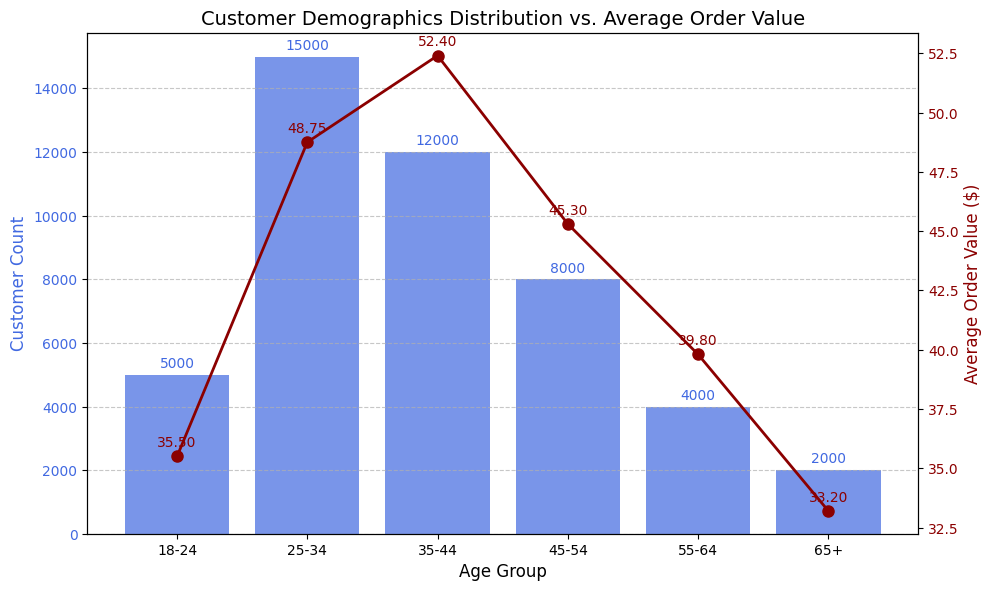What age group has the highest customer count? The bar representing the 25-34 age group is higher than the others, indicating that this group has the highest customer count.
Answer: 25-34 Which age group has the lowest average order value? The line plot shows the 65+ age group has the lowest value point, indicating the lowest average order value.
Answer: 65+ What is the difference in customer count between the 25-34 and 35-44 age groups? The customer count for the 25-34 age group is 15000, and for the 35-44 age group is 12000. The difference is 15000 - 12000.
Answer: 3000 Which age group has a higher average order value, 18-24 or 55-64? By comparing the points on the line plot, the 55-64 age group has a higher value of $39.80 compared to $35.50 for the 18-24 age group.
Answer: 55-64 What is the summed average order value of the 25-34 and 45-54 age groups? The average order value for 25-34 is $48.75, and for 45-54 is $45.30. Summing them gives 48.75 + 45.30.
Answer: 94.05 Is the customer count for the 18-24 age group less than half of the customer count for the 35-44 age group? The 18-24 age group has 5000 customers. Half of the 35-44 age group’s customer count of 12000 is 6000. Since 5000 < 6000, the answer is yes.
Answer: Yes What’s the average customer count for all age groups? Summing all customer counts: 5000 + 15000 + 12000 + 8000 + 4000 + 2000 = 46000. Dividing by 6 age groups: 46000 / 6.
Answer: 7666.67 If you combine the customer counts of the 55-64 and 65+ age groups, how does that compare to the 45-54 age group? The customer counts for 55-64 and 65+ are 4000 and 2000, respectively. Combined, they are 6000. The 45-54 age group has 8000; hence, 6000 < 8000.
Answer: Less What’s the total average order value for all age groups combined? The sum of the average order values is 35.50 + 48.75 + 52.40 + 45.30 + 39.80 + 33.20. The total is 254.95.
Answer: 254.95 Which age group has the highest average order value and what is it? The highest point on the line plot corresponds to the 35-44 age group at $52.40.
Answer: 35-44, $52.40 